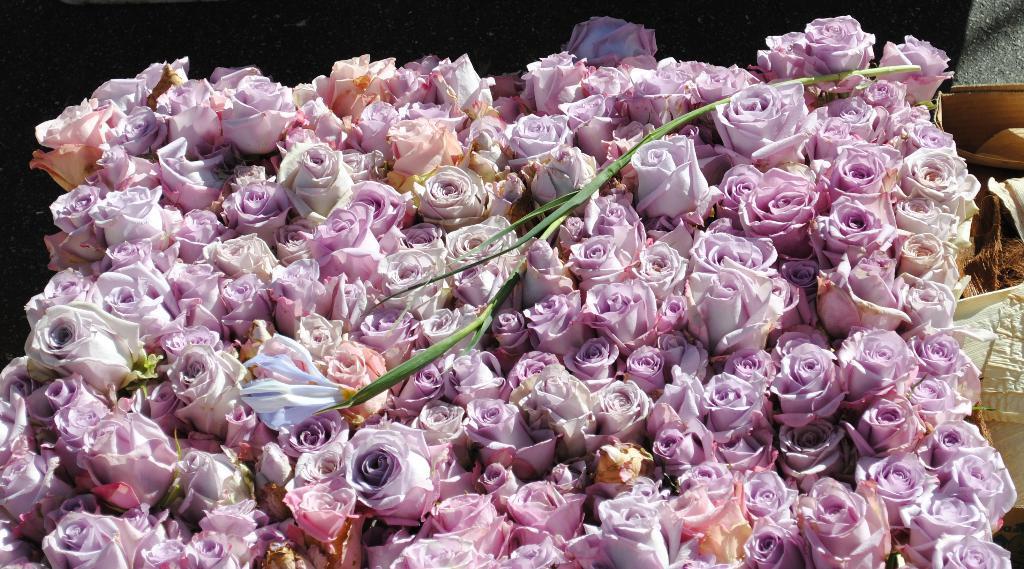In one or two sentences, can you explain what this image depicts? Here there are pink color flowers. 